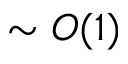Convert formula to latex. <formula><loc_0><loc_0><loc_500><loc_500>\sim O ( 1 )</formula> 